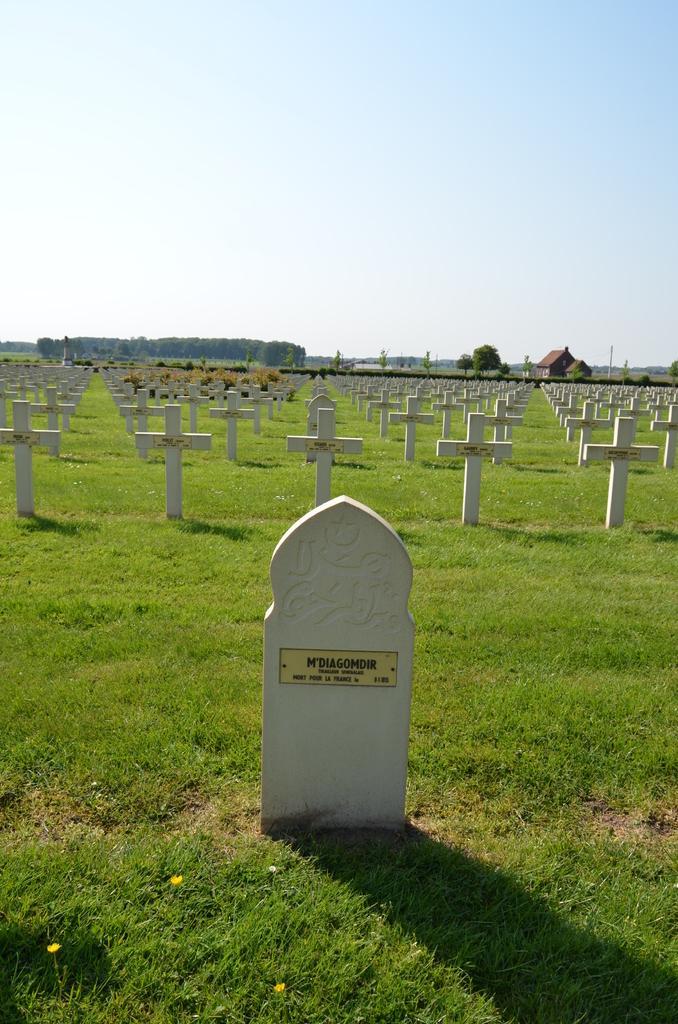Could you give a brief overview of what you see in this image? This is the image of a graveyard. Background of the image trees and houses are present. 